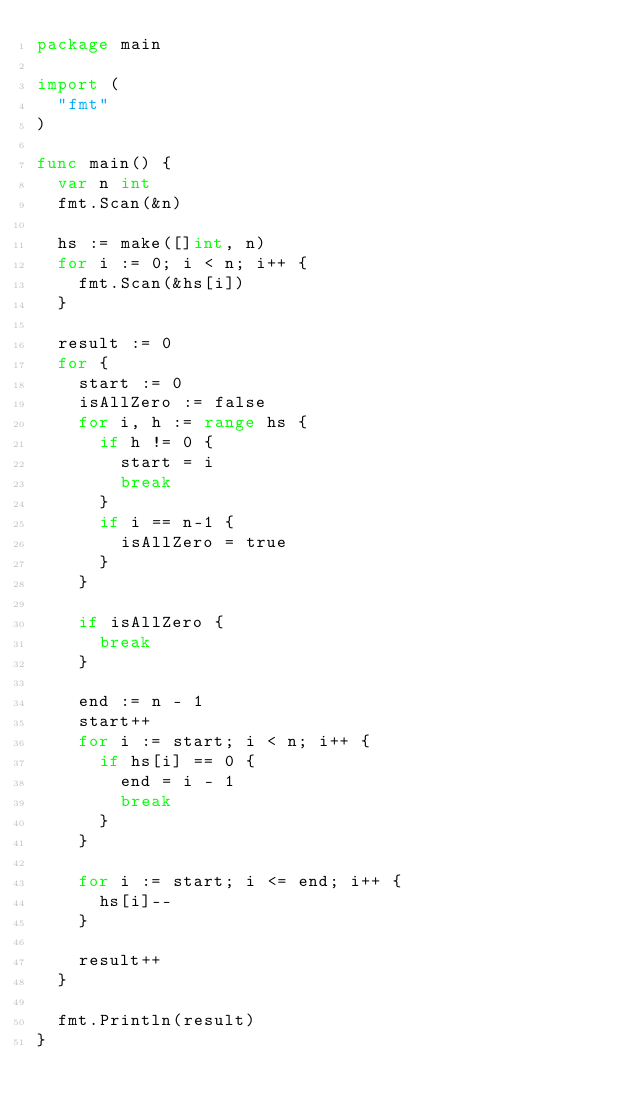<code> <loc_0><loc_0><loc_500><loc_500><_Go_>package main

import (
	"fmt"
)

func main() {
	var n int
	fmt.Scan(&n)

	hs := make([]int, n)
	for i := 0; i < n; i++ {
		fmt.Scan(&hs[i])
	}

	result := 0
	for {
		start := 0
		isAllZero := false
		for i, h := range hs {
			if h != 0 {
				start = i
				break
			}
			if i == n-1 {
				isAllZero = true
			}
		}

		if isAllZero {
			break
		}

		end := n - 1
		start++
		for i := start; i < n; i++ {
			if hs[i] == 0 {
				end = i - 1
				break
			}
		}

		for i := start; i <= end; i++ {
			hs[i]--
		}

		result++
	}

	fmt.Println(result)
}
</code> 